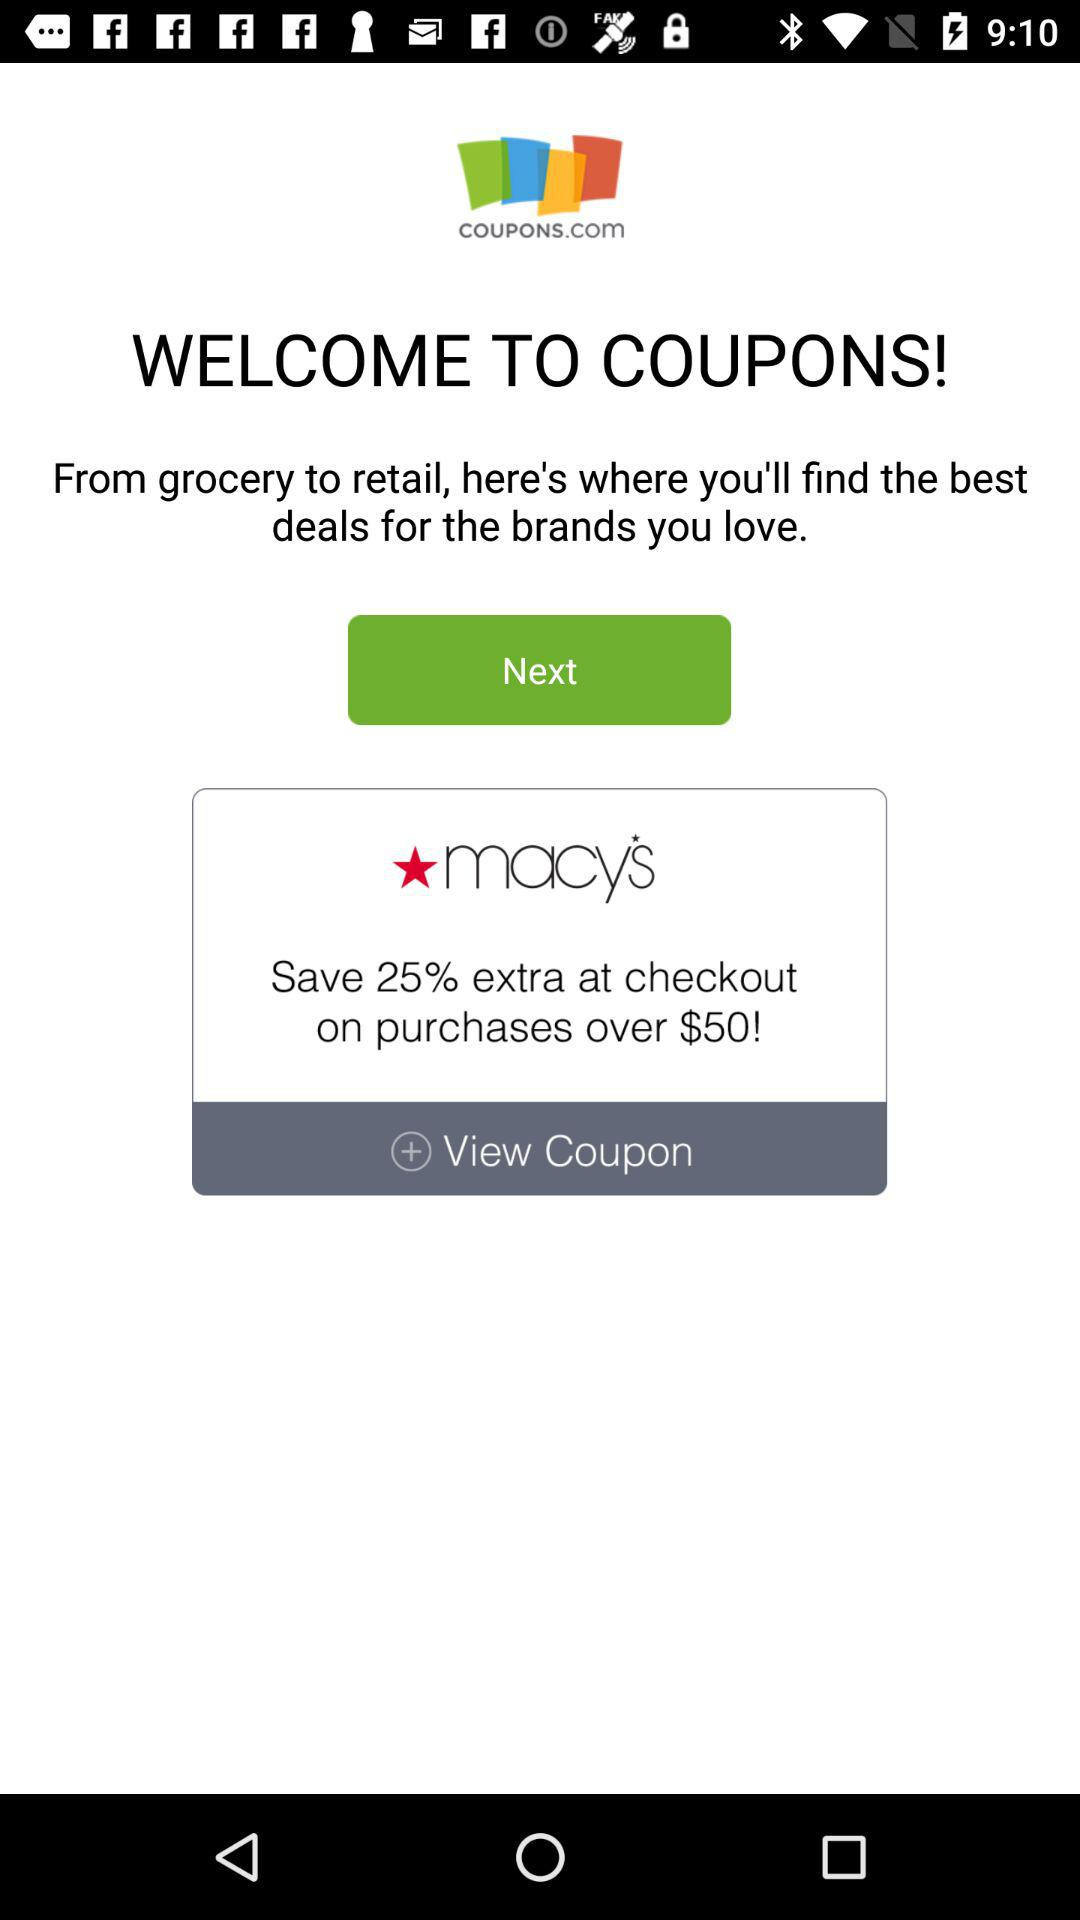For which retailer is the next coupon?
When the provided information is insufficient, respond with <no answer>. <no answer> 